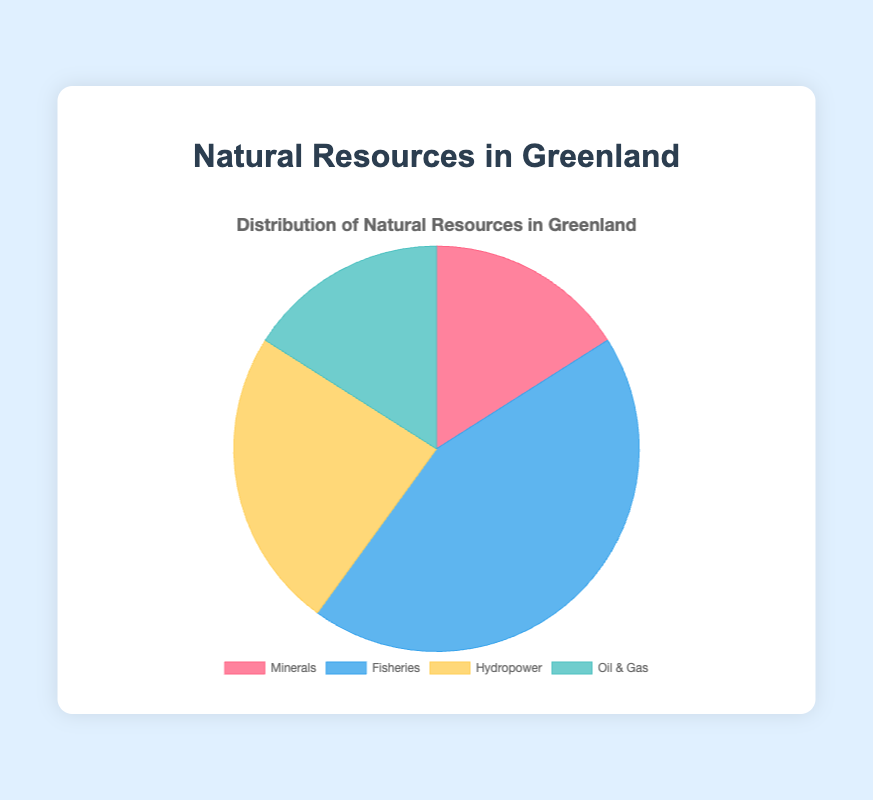What's the total percentage of natural resources from Fisheries and Hydropower combined? The visual data shows Fisheries at 55% and Hydropower at 30%. Adding these two percentages gives 55 + 30 = 85%.
Answer: 85% Which category of natural resources has the smallest share, and what is its percentage? Examining the pie chart, Minerals and Oil & Gas each contribute 20%, which are the smallest shares compared to other categories
Answer: Minerals and Oil & Gas at 20% If you combine the percentages of Oil & Gas and Minerals, does the combined share exceed the share of Fisheries? The Oil & Gas category contributes 20% and Minerals also contribute 20%. Combining them gives 20 + 20 = 40%, which is less than the Fisheries share of 55%.
Answer: No, 40% Which category is represented by the color blue, and what is its percentage? According to the visual cue, the category Fisheries is represented by blue, and its percentage is shown as 55%.
Answer: Fisheries at 55% Rank the categories from highest to lowest percentage. By examining the chart, Hydropower is the highest at 30%, followed by Fisheries at 55%, and then Oil & Gas and Minerals both at 20%.
Answer: Fisheries > Hydropower > Minerals, Oil & Gas Compare the total percentage of 'Rare Earth Elements', 'Zinc', 'Gold', and 'Iron ore' with 'Hydroelectric Energy'. Total percentage: Rare Earth Elements 10% + Zinc 5% + Gold 3% + Iron ore 2% = 20%. Hydroelectric Energy percentage is 30%.
Answer: 20% < 30% What color represents the Minerals category, and what is its percentage? The chart shows Minerals in red, contributing 20%.
Answer: Red, 20% What is the percentage difference between the largest and smallest resource categories? The largest percentage is Fisheries at 55%, and the smallest individual categories are Oil & Gas or Minerals both at 20%. The difference is 55 - 20 = 35%.
Answer: 35% Which is more: the percentage of Oil & Gas or the combined percentage of Capelin and Cod? Oil & Gas category is 20%, Capelin is 5% and Cod is 10%. Their combined value is 5 + 10 = 15%, which is less than 20%.
Answer: Oil & Gas at 20% If the total percentage for Oil & Gas increases by 5%, will it surpass Hydropower? Oil & Gas initially at 20%, with an increase of 5% it would be 20 + 5 = 25%, still less than Hydropower at 30%.
Answer: No, 25% 